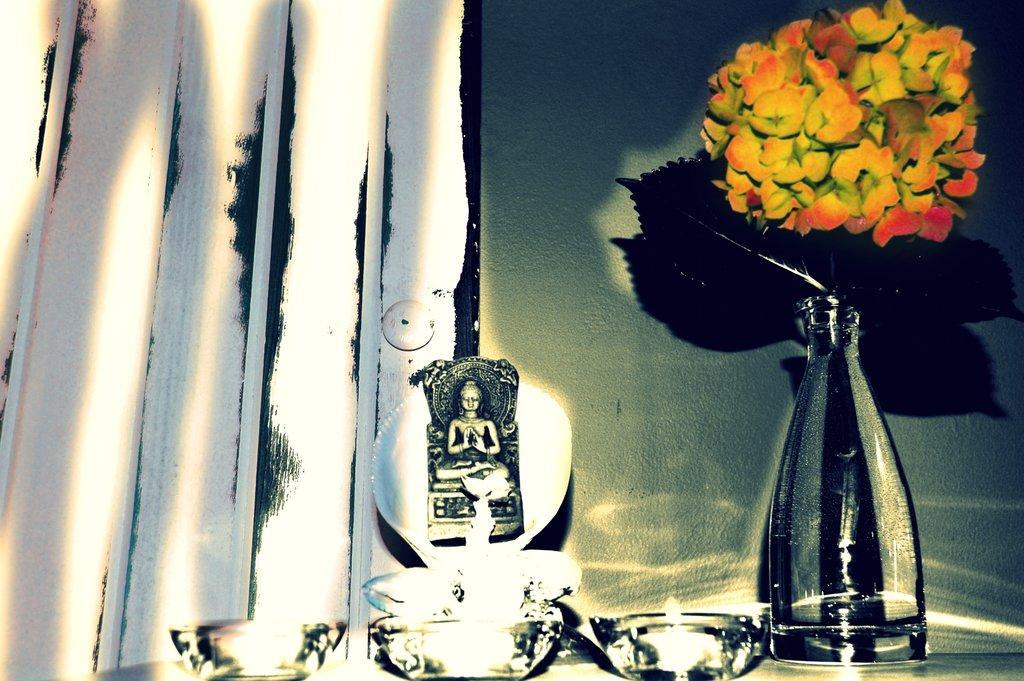Describe this image in one or two sentences. In this image I can see few flowers in a pot. I can also see a sculpture over here and I can see colour of these flowers are yellow and orange. 